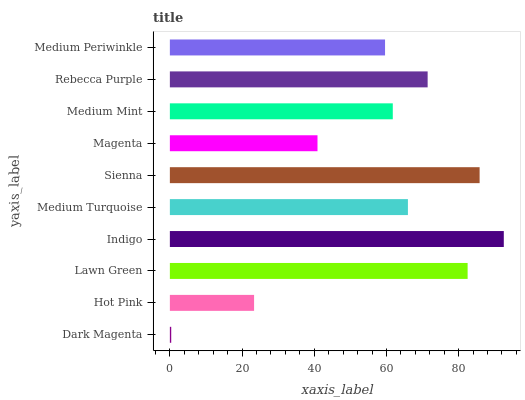Is Dark Magenta the minimum?
Answer yes or no. Yes. Is Indigo the maximum?
Answer yes or no. Yes. Is Hot Pink the minimum?
Answer yes or no. No. Is Hot Pink the maximum?
Answer yes or no. No. Is Hot Pink greater than Dark Magenta?
Answer yes or no. Yes. Is Dark Magenta less than Hot Pink?
Answer yes or no. Yes. Is Dark Magenta greater than Hot Pink?
Answer yes or no. No. Is Hot Pink less than Dark Magenta?
Answer yes or no. No. Is Medium Turquoise the high median?
Answer yes or no. Yes. Is Medium Mint the low median?
Answer yes or no. Yes. Is Sienna the high median?
Answer yes or no. No. Is Rebecca Purple the low median?
Answer yes or no. No. 